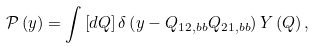Convert formula to latex. <formula><loc_0><loc_0><loc_500><loc_500>\mathcal { P } \left ( y \right ) = \int \left [ d Q \right ] \delta \left ( y - Q _ { 1 2 , b b } Q _ { 2 1 , b b } \right ) Y \left ( Q \right ) ,</formula> 